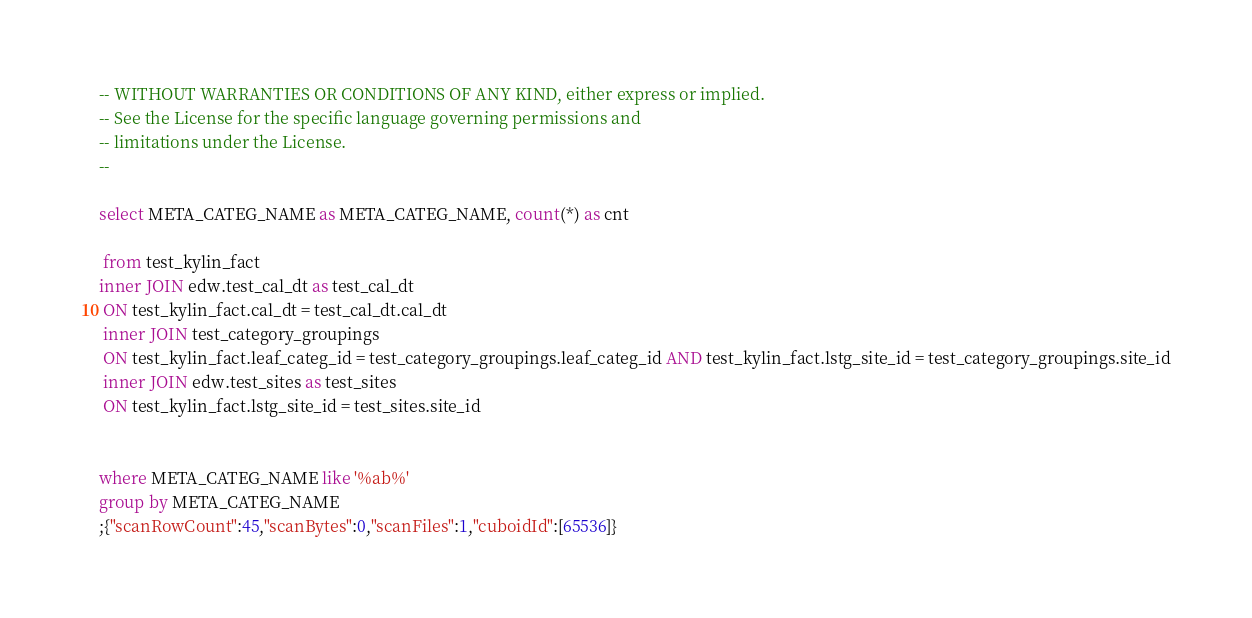Convert code to text. <code><loc_0><loc_0><loc_500><loc_500><_SQL_>-- WITHOUT WARRANTIES OR CONDITIONS OF ANY KIND, either express or implied.
-- See the License for the specific language governing permissions and
-- limitations under the License.
--

select META_CATEG_NAME as META_CATEG_NAME, count(*) as cnt 
 
 from test_kylin_fact 
inner JOIN edw.test_cal_dt as test_cal_dt
 ON test_kylin_fact.cal_dt = test_cal_dt.cal_dt
 inner JOIN test_category_groupings
 ON test_kylin_fact.leaf_categ_id = test_category_groupings.leaf_categ_id AND test_kylin_fact.lstg_site_id = test_category_groupings.site_id
 inner JOIN edw.test_sites as test_sites
 ON test_kylin_fact.lstg_site_id = test_sites.site_id
 
 
where META_CATEG_NAME like '%ab%'
group by META_CATEG_NAME
;{"scanRowCount":45,"scanBytes":0,"scanFiles":1,"cuboidId":[65536]}</code> 